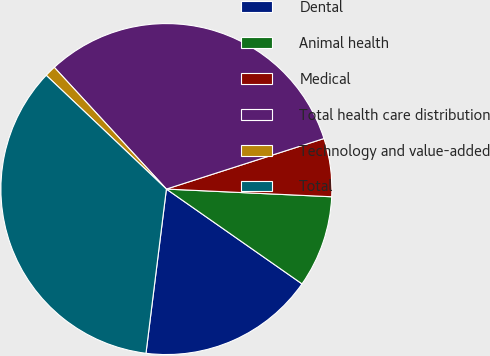Convert chart. <chart><loc_0><loc_0><loc_500><loc_500><pie_chart><fcel>Dental<fcel>Animal health<fcel>Medical<fcel>Total health care distribution<fcel>Technology and value-added<fcel>Total<nl><fcel>17.26%<fcel>8.97%<fcel>5.68%<fcel>31.91%<fcel>1.09%<fcel>35.1%<nl></chart> 